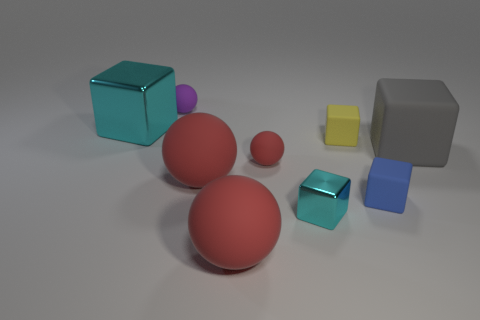There is a gray matte cube; are there any small objects on the right side of it?
Keep it short and to the point. No. There is another yellow thing that is the same shape as the large metallic object; what is its material?
Your answer should be very brief. Rubber. Is there any other thing that is made of the same material as the yellow cube?
Your answer should be very brief. Yes. What number of other objects are the same shape as the yellow matte object?
Your answer should be very brief. 4. There is a big object behind the matte object right of the blue object; how many tiny things are to the left of it?
Your answer should be compact. 0. How many yellow matte objects have the same shape as the gray rubber thing?
Keep it short and to the point. 1. Do the big matte thing right of the small red matte sphere and the tiny shiny object have the same color?
Your answer should be compact. No. What shape is the tiny cyan metallic thing in front of the large cyan shiny object that is on the left side of the red thing in front of the small blue matte object?
Your response must be concise. Cube. Do the yellow matte thing and the cyan shiny thing behind the blue thing have the same size?
Ensure brevity in your answer.  No. Is there a red ball of the same size as the blue block?
Give a very brief answer. Yes. 